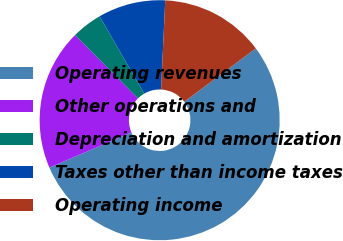<chart> <loc_0><loc_0><loc_500><loc_500><pie_chart><fcel>Operating revenues<fcel>Other operations and<fcel>Depreciation and amortization<fcel>Taxes other than income taxes<fcel>Operating income<nl><fcel>53.74%<fcel>19.01%<fcel>4.12%<fcel>9.08%<fcel>14.05%<nl></chart> 